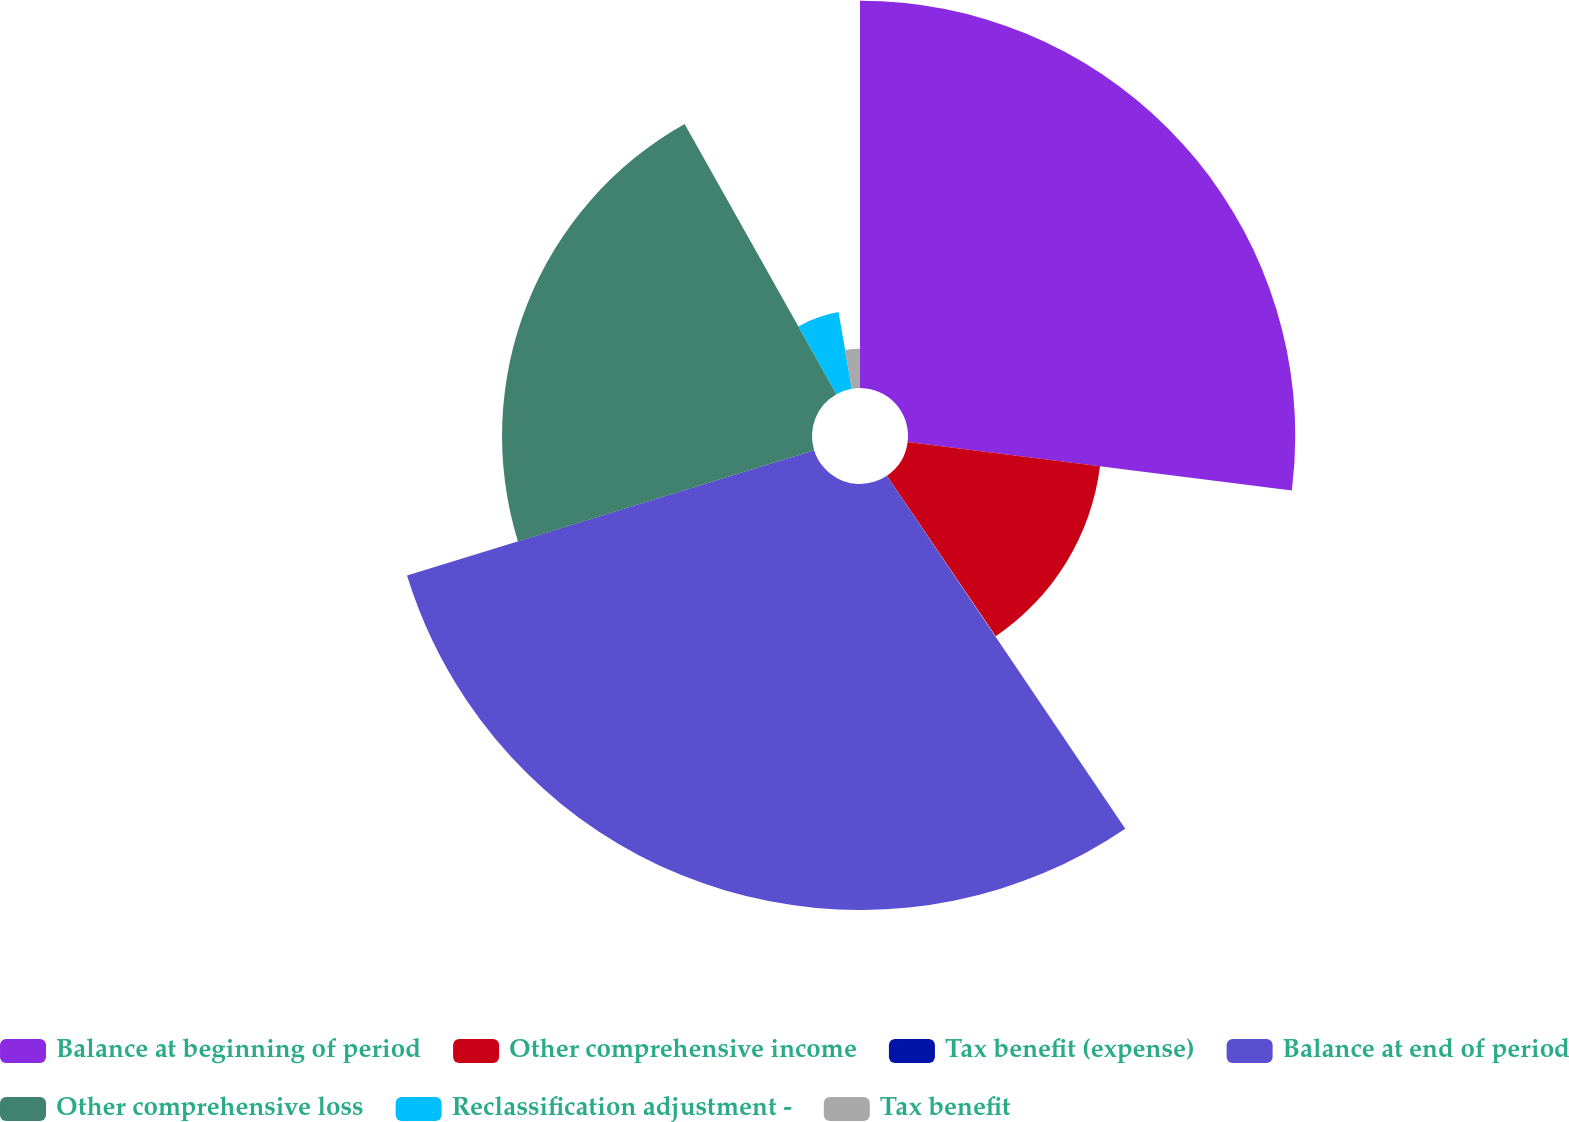Convert chart to OTSL. <chart><loc_0><loc_0><loc_500><loc_500><pie_chart><fcel>Balance at beginning of period<fcel>Other comprehensive income<fcel>Tax benefit (expense)<fcel>Balance at end of period<fcel>Other comprehensive loss<fcel>Reclassification adjustment -<fcel>Tax benefit<nl><fcel>27.0%<fcel>13.52%<fcel>0.03%<fcel>29.7%<fcel>21.61%<fcel>5.42%<fcel>2.73%<nl></chart> 